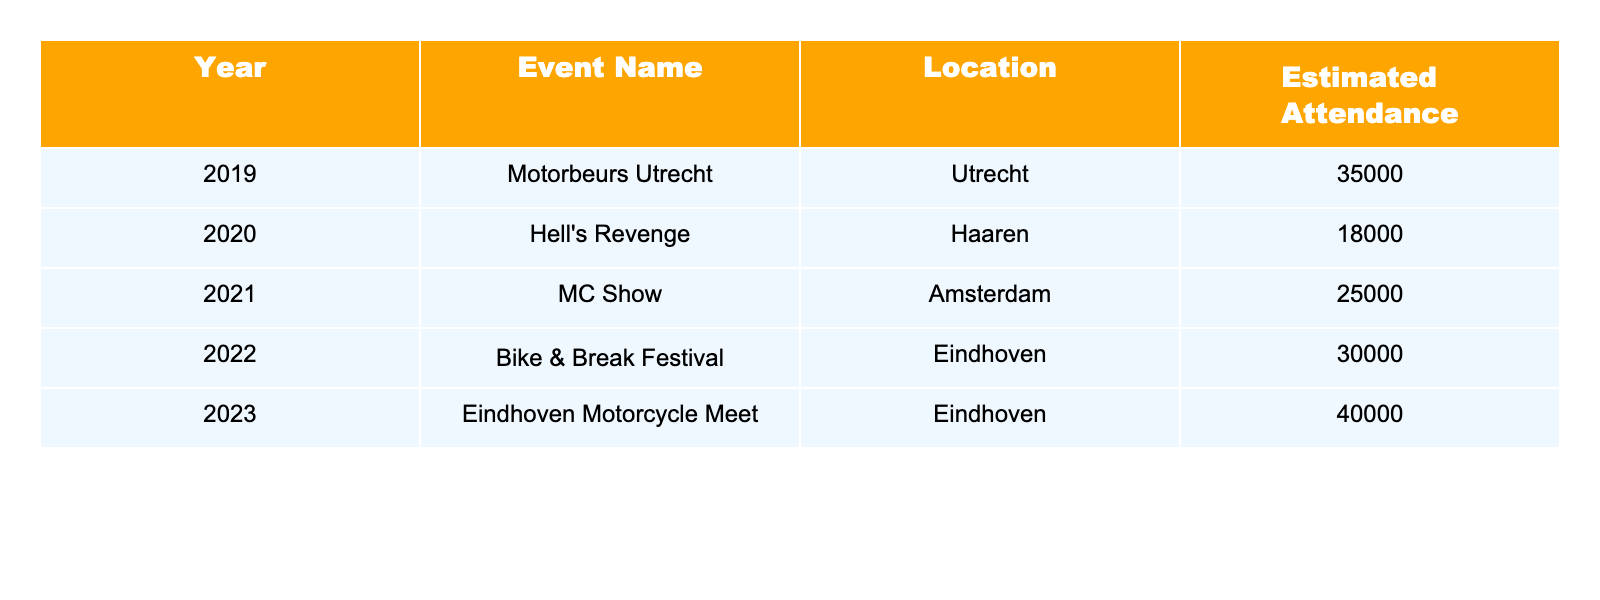What was the estimated attendance for the Motorbeurs Utrecht in 2019? The table states the estimated attendance for the Motorbeurs Utrecht in 2019 is 35,000.
Answer: 35,000 Which event had the highest attendance between 2019 and 2023? In the table, the highest attendance is recorded for the Eindhoven Motorcycle Meet in 2023, with 40,000 attendees.
Answer: 40,000 What is the total estimated attendance across all events from 2019 to 2023? Adding the estimated attendance for each event: 35,000 + 18,000 + 25,000 + 30,000 + 40,000 = 148,000.
Answer: 148,000 Was the attendance for the Hell's Revenge event higher than the MC Show in 2021? The attendance for Hell's Revenge in 2020 is 18,000, and for MC Show in 2021, it is 25,000. Thus, 18,000 is not higher than 25,000.
Answer: No What was the average attendance for the events held in 2022 and 2023? To find the average, sum the attendances for Bike & Break Festival (30,000) and Eindhoven Motorcycle Meet (40,000) which is 30,000 + 40,000 = 70,000, and then divide by 2 (the number of events), so 70,000 / 2 = 35,000.
Answer: 35,000 Which location had the most motorcycle events listed in this table? The table has two events listed in Eindhoven in 2022 and 2023, and one event each in Utrecht, Haaren, and Amsterdam. Therefore, Eindhoven has the most events.
Answer: Eindhoven If we consider only the years 2020 to 2023, what was the percentage increase in estimated attendance from the Hell's Revenge event to the Eindhoven Motorcycle Meet? The attendance increased from 18,000 (2020) to 40,000 (2023). The difference is 40,000 - 18,000 = 22,000. To find the percentage increase: (22,000 / 18,000) * 100 = 122.22, which represents a significant increase over the three years.
Answer: 122.22% What was the attendance differential between the event with the lowest attendance and the highest attendance in this table? The lowest attendance is for Hell's Revenge (18,000) and the highest is for the Eindhoven Motorcycle Meet (40,000). The differential is 40,000 - 18,000 = 22,000.
Answer: 22,000 Which year had the second highest estimated attendance? The highest attendance is in 2023 with 40,000 and the second highest is for Bike & Break Festival in 2022 with 30,000.
Answer: 30,000 How many years had an attendance exceeding 25,000? The years 2019 (35,000), 2021 (25,000), 2022 (30,000), and 2023 (40,000) all had attendances exceeding 25,000, totaling four years.
Answer: 4 